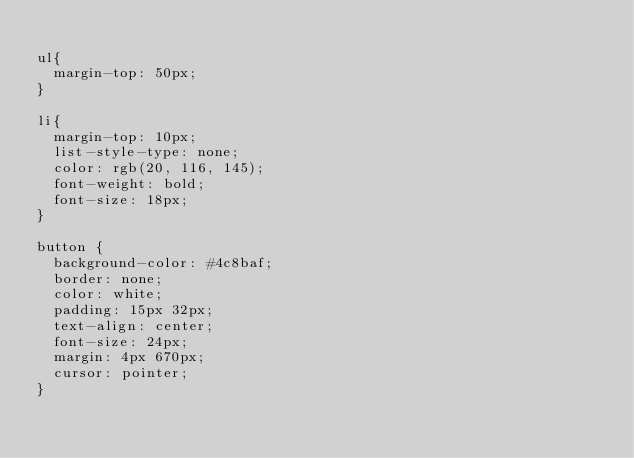<code> <loc_0><loc_0><loc_500><loc_500><_CSS_>
ul{
  margin-top: 50px;
}

li{
  margin-top: 10px;
  list-style-type: none;
  color: rgb(20, 116, 145);
  font-weight: bold;
  font-size: 18px;
}

button {
  background-color: #4c8baf;
  border: none;
  color: white;
  padding: 15px 32px;
  text-align: center;
  font-size: 24px;
  margin: 4px 670px;
  cursor: pointer;
}

</code> 